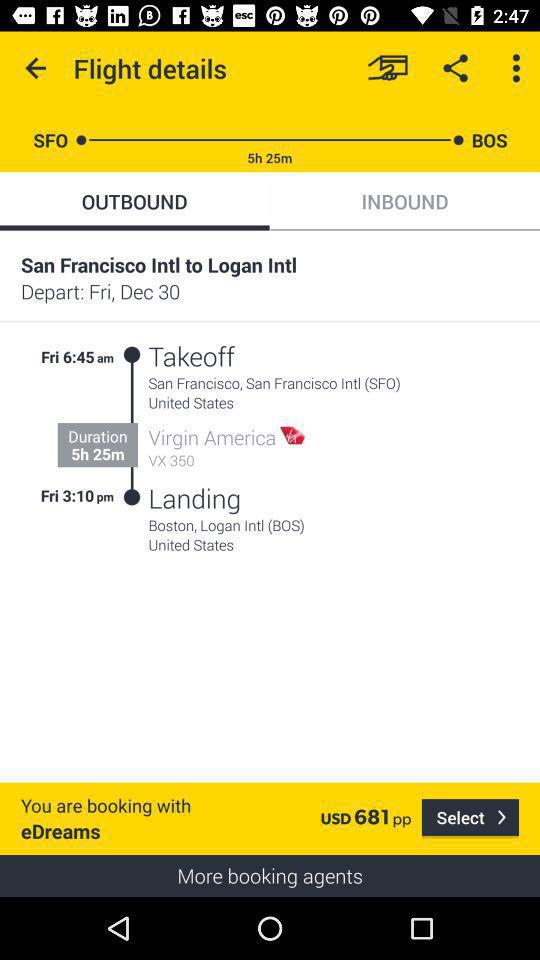What's the takeoff time? The takeoff time is 6:45 a.m. 